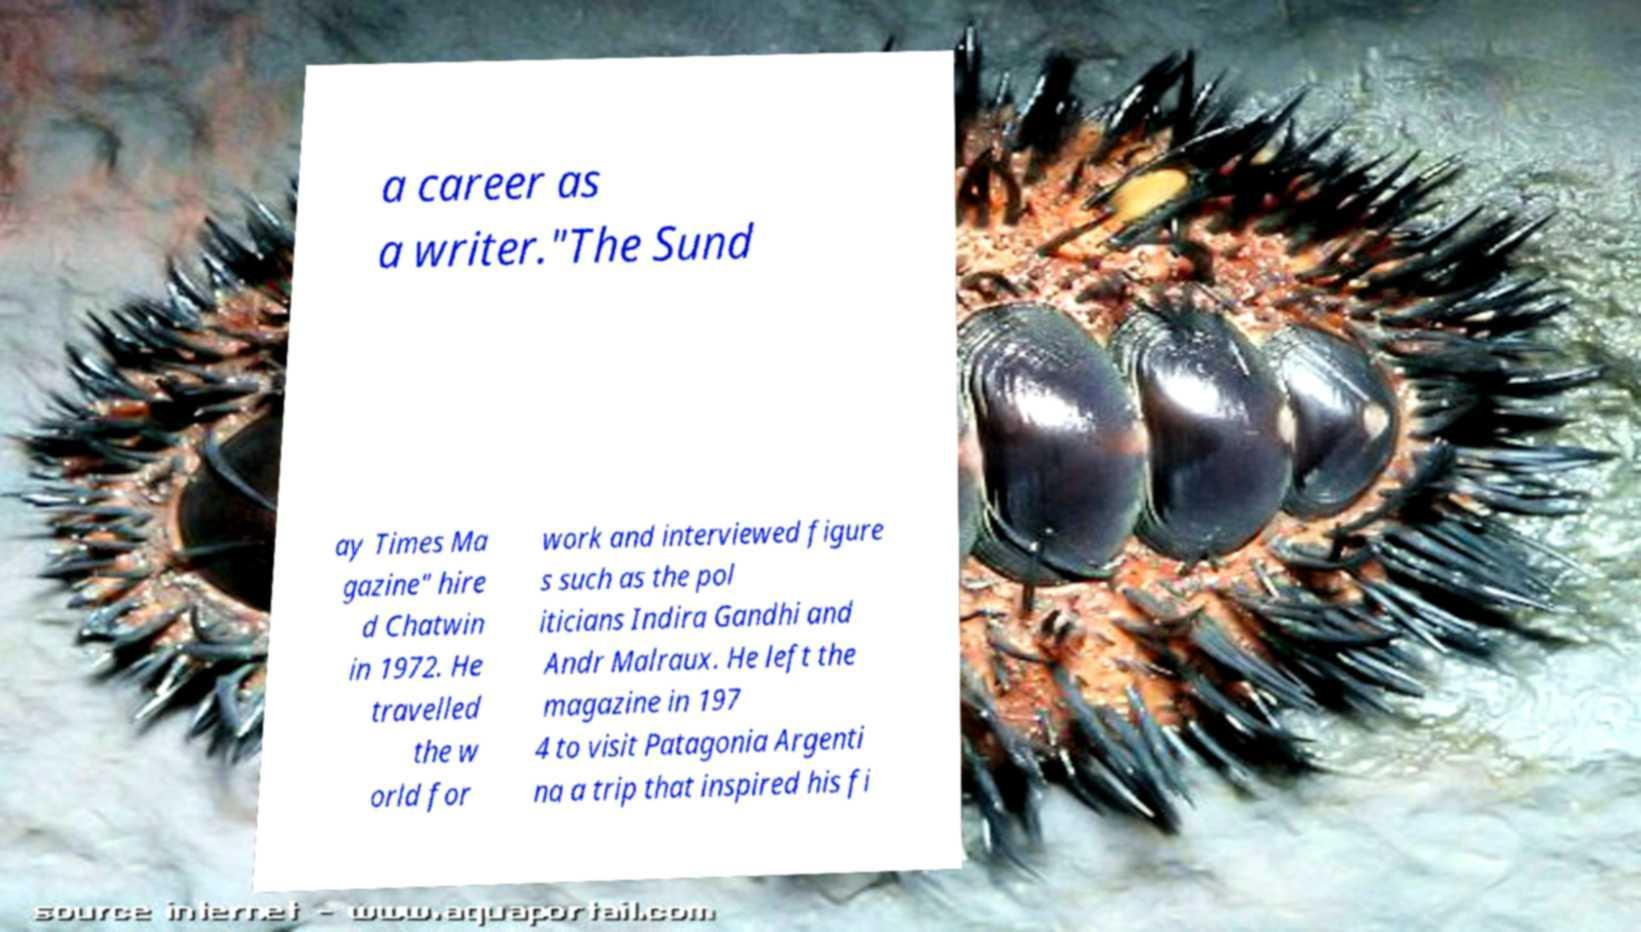Can you accurately transcribe the text from the provided image for me? a career as a writer."The Sund ay Times Ma gazine" hire d Chatwin in 1972. He travelled the w orld for work and interviewed figure s such as the pol iticians Indira Gandhi and Andr Malraux. He left the magazine in 197 4 to visit Patagonia Argenti na a trip that inspired his fi 